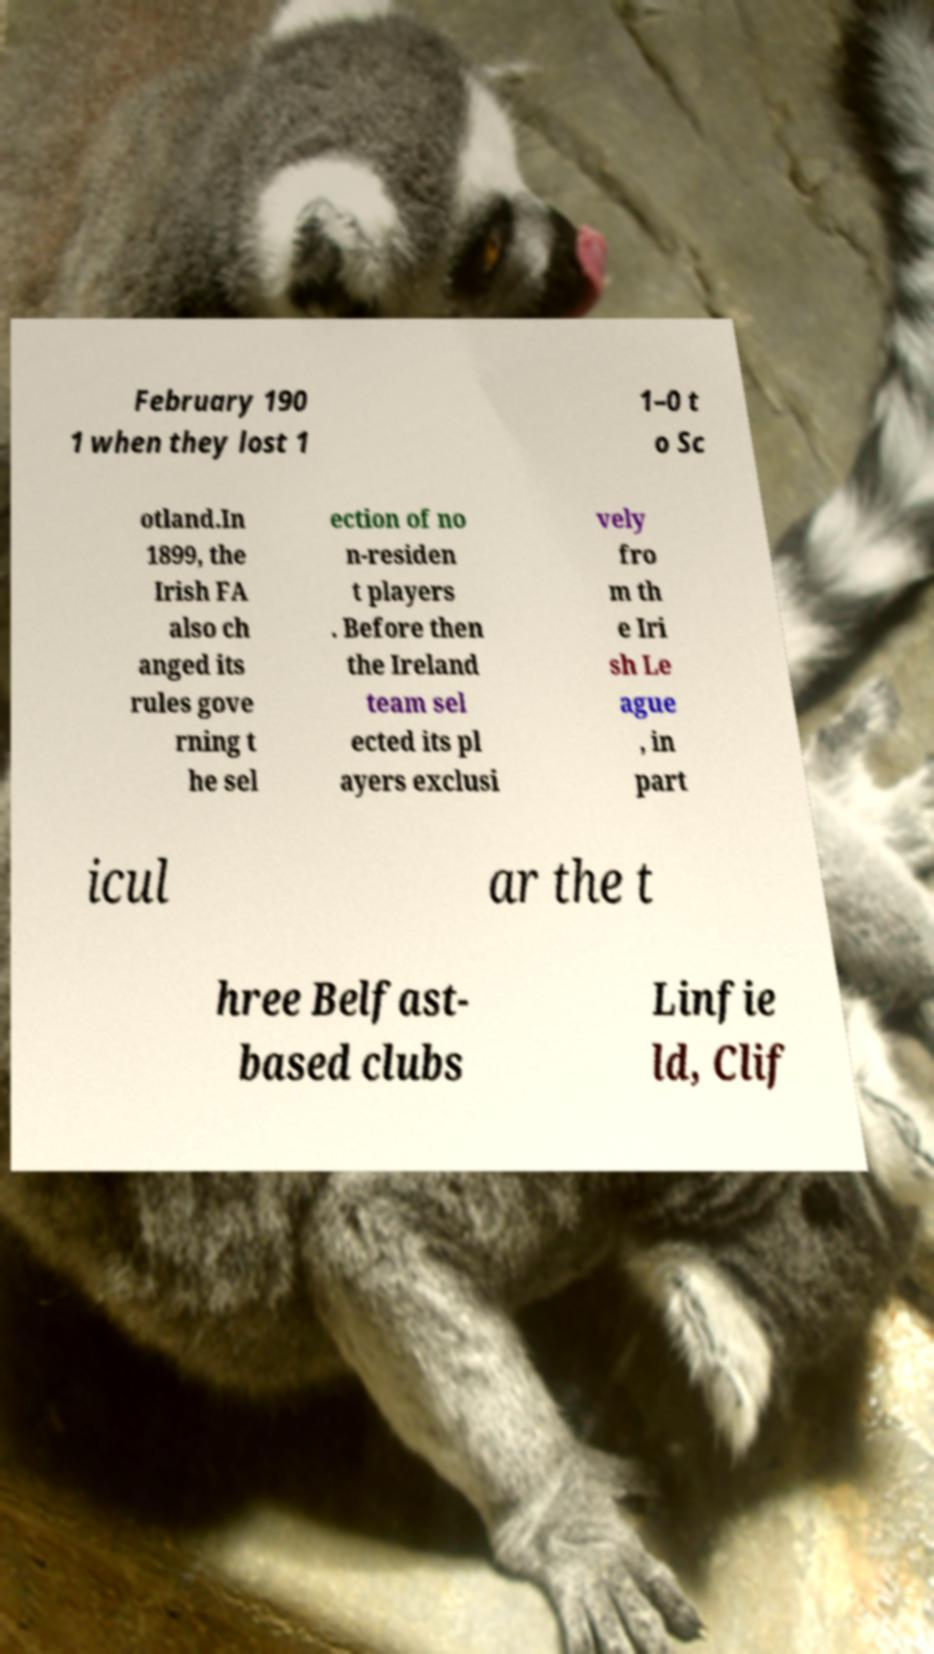There's text embedded in this image that I need extracted. Can you transcribe it verbatim? February 190 1 when they lost 1 1–0 t o Sc otland.In 1899, the Irish FA also ch anged its rules gove rning t he sel ection of no n-residen t players . Before then the Ireland team sel ected its pl ayers exclusi vely fro m th e Iri sh Le ague , in part icul ar the t hree Belfast- based clubs Linfie ld, Clif 